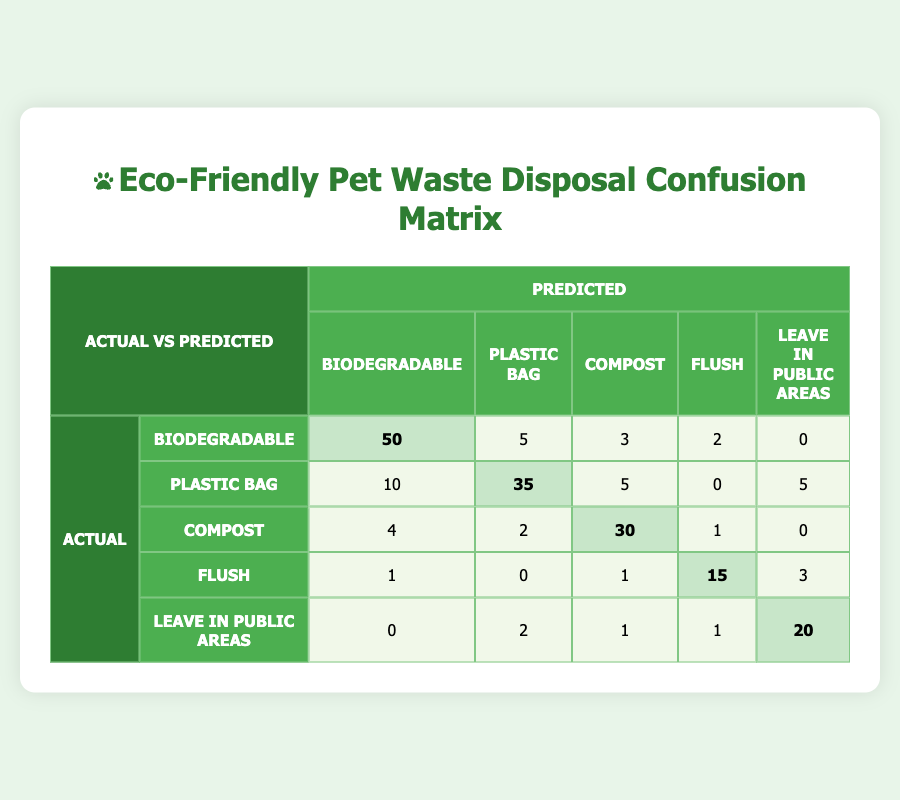What is the count of predicted biodegradable waste disposal practices that were actually biodegradable? From the table, the cell corresponding to actual and predicted being both "Biodegradable" shows a count of 50.
Answer: 50 What is the predicted count for the practice "Leave in Public Areas"? To find this, we look at the row for "Leave in Public Areas," which shows predictions: Biodegradable: 0, Plastic Bag: 2, Compost: 1, Flush: 1, and Leave in Public Areas: 20. The counts add up to 24.
Answer: 24 How many times was "Compost" correctly predicted? The diagonal cell in the "Compost" row and "Compost" column shows a count of 30, indicating the correct predictions for this category.
Answer: 30 What is the total number of predictions made for the "Plastic Bag" category? For this category, we need to sum the counts in the entire row: 10 + 35 + 5 + 0 + 5 = 55. The total predictions for "Plastic Bag" are therefore 55.
Answer: 55 Is it true that the count of "Flush" predicted as "Leave in Public Areas" is higher than those predicted as "Biodegradable"? The count for "Flush" predicted as "Leave in Public Areas" is 3, while for "Flush" predicted as "Biodegradable" it is 1. Thus, the assertion is true since 3 > 1.
Answer: True What is the combined total of all correctly predicted practices for "Biodegradable" and "Compost"? The correctly predicted "Biodegradable" count is 50, and "Compost" count is 30. Adding these gives us 50 + 30 = 80.
Answer: 80 How many cases of "Leave in Public Areas" were predicted as "Plastic Bag"? In the row for "Leave in Public Areas" under the "Plastic Bag" column, the count shows 2 cases.
Answer: 2 If 10 more predictions were added for "Compost" being misclassified to "Plastic Bag", what would be their new counts? Currently, the count of "Compost" misclassified as "Plastic Bag" is 2, so adding 10 gives us 2 + 10 = 12. The new count would be 12.
Answer: 12 What is the total number of mispredictions for the "Flush" category? To find mispredictions for "Flush," sum the counts not on the diagonal: 1 (to Biodegradable) + 0 (to Plastic Bag) + 1 (to Compost) + 3 (to Leave in Public Areas) = 5.
Answer: 5 